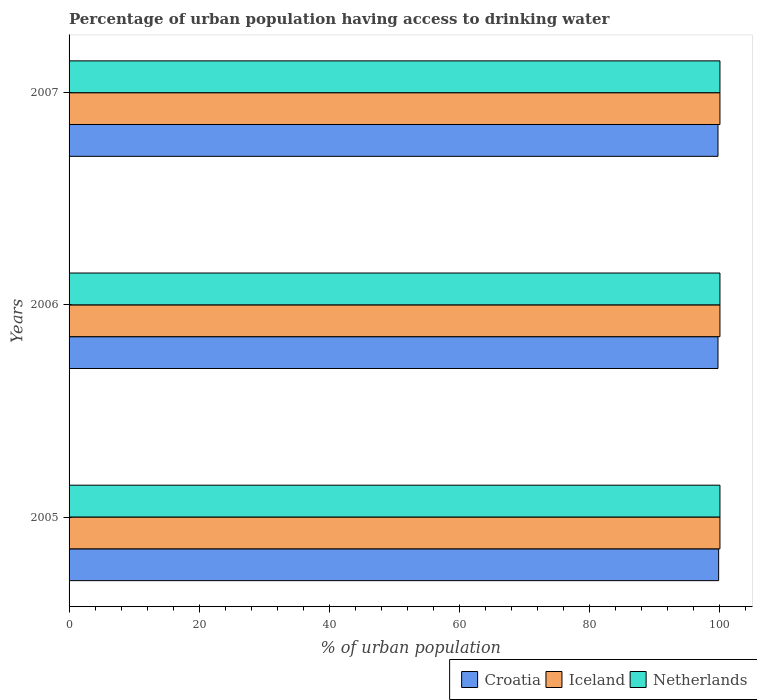How many different coloured bars are there?
Your answer should be compact. 3. How many groups of bars are there?
Keep it short and to the point. 3. Are the number of bars on each tick of the Y-axis equal?
Make the answer very short. Yes. How many bars are there on the 1st tick from the bottom?
Offer a very short reply. 3. What is the percentage of urban population having access to drinking water in Netherlands in 2005?
Your answer should be very brief. 100. Across all years, what is the maximum percentage of urban population having access to drinking water in Croatia?
Give a very brief answer. 99.8. Across all years, what is the minimum percentage of urban population having access to drinking water in Iceland?
Your answer should be very brief. 100. In which year was the percentage of urban population having access to drinking water in Croatia minimum?
Your answer should be very brief. 2006. What is the total percentage of urban population having access to drinking water in Croatia in the graph?
Keep it short and to the point. 299.2. What is the difference between the percentage of urban population having access to drinking water in Netherlands in 2006 and the percentage of urban population having access to drinking water in Croatia in 2005?
Your response must be concise. 0.2. What is the average percentage of urban population having access to drinking water in Iceland per year?
Your answer should be compact. 100. In the year 2006, what is the difference between the percentage of urban population having access to drinking water in Iceland and percentage of urban population having access to drinking water in Croatia?
Make the answer very short. 0.3. In how many years, is the percentage of urban population having access to drinking water in Iceland greater than 48 %?
Make the answer very short. 3. What is the difference between the highest and the lowest percentage of urban population having access to drinking water in Netherlands?
Ensure brevity in your answer.  0. In how many years, is the percentage of urban population having access to drinking water in Croatia greater than the average percentage of urban population having access to drinking water in Croatia taken over all years?
Offer a very short reply. 1. Is the sum of the percentage of urban population having access to drinking water in Iceland in 2006 and 2007 greater than the maximum percentage of urban population having access to drinking water in Croatia across all years?
Provide a succinct answer. Yes. What does the 2nd bar from the bottom in 2007 represents?
Your answer should be very brief. Iceland. Are all the bars in the graph horizontal?
Offer a very short reply. Yes. How many years are there in the graph?
Ensure brevity in your answer.  3. What is the difference between two consecutive major ticks on the X-axis?
Your answer should be very brief. 20. Does the graph contain any zero values?
Your answer should be very brief. No. Does the graph contain grids?
Make the answer very short. No. Where does the legend appear in the graph?
Offer a terse response. Bottom right. What is the title of the graph?
Keep it short and to the point. Percentage of urban population having access to drinking water. What is the label or title of the X-axis?
Your response must be concise. % of urban population. What is the label or title of the Y-axis?
Keep it short and to the point. Years. What is the % of urban population of Croatia in 2005?
Provide a succinct answer. 99.8. What is the % of urban population of Croatia in 2006?
Your answer should be very brief. 99.7. What is the % of urban population in Croatia in 2007?
Offer a terse response. 99.7. What is the % of urban population in Iceland in 2007?
Your response must be concise. 100. Across all years, what is the maximum % of urban population in Croatia?
Your answer should be compact. 99.8. Across all years, what is the maximum % of urban population in Iceland?
Your answer should be very brief. 100. Across all years, what is the maximum % of urban population of Netherlands?
Offer a very short reply. 100. Across all years, what is the minimum % of urban population in Croatia?
Keep it short and to the point. 99.7. Across all years, what is the minimum % of urban population in Iceland?
Keep it short and to the point. 100. What is the total % of urban population of Croatia in the graph?
Give a very brief answer. 299.2. What is the total % of urban population of Iceland in the graph?
Your answer should be compact. 300. What is the total % of urban population in Netherlands in the graph?
Provide a succinct answer. 300. What is the difference between the % of urban population in Iceland in 2005 and that in 2006?
Provide a succinct answer. 0. What is the difference between the % of urban population in Netherlands in 2005 and that in 2006?
Your answer should be compact. 0. What is the difference between the % of urban population of Croatia in 2005 and that in 2007?
Offer a very short reply. 0.1. What is the difference between the % of urban population in Iceland in 2005 and that in 2007?
Provide a short and direct response. 0. What is the difference between the % of urban population in Netherlands in 2005 and that in 2007?
Provide a short and direct response. 0. What is the difference between the % of urban population of Croatia in 2006 and that in 2007?
Your answer should be very brief. 0. What is the difference between the % of urban population of Iceland in 2006 and that in 2007?
Your answer should be compact. 0. What is the difference between the % of urban population in Netherlands in 2006 and that in 2007?
Your response must be concise. 0. What is the difference between the % of urban population of Croatia in 2005 and the % of urban population of Iceland in 2006?
Your answer should be very brief. -0.2. What is the difference between the % of urban population of Croatia in 2005 and the % of urban population of Iceland in 2007?
Offer a very short reply. -0.2. What is the difference between the % of urban population in Croatia in 2005 and the % of urban population in Netherlands in 2007?
Keep it short and to the point. -0.2. What is the difference between the % of urban population in Croatia in 2006 and the % of urban population in Iceland in 2007?
Provide a short and direct response. -0.3. What is the difference between the % of urban population of Iceland in 2006 and the % of urban population of Netherlands in 2007?
Provide a short and direct response. 0. What is the average % of urban population of Croatia per year?
Your response must be concise. 99.73. What is the average % of urban population in Iceland per year?
Provide a succinct answer. 100. What is the average % of urban population in Netherlands per year?
Make the answer very short. 100. In the year 2005, what is the difference between the % of urban population in Croatia and % of urban population in Iceland?
Offer a terse response. -0.2. In the year 2005, what is the difference between the % of urban population of Croatia and % of urban population of Netherlands?
Ensure brevity in your answer.  -0.2. In the year 2006, what is the difference between the % of urban population of Croatia and % of urban population of Iceland?
Your answer should be compact. -0.3. In the year 2006, what is the difference between the % of urban population in Croatia and % of urban population in Netherlands?
Give a very brief answer. -0.3. In the year 2006, what is the difference between the % of urban population in Iceland and % of urban population in Netherlands?
Offer a terse response. 0. In the year 2007, what is the difference between the % of urban population of Croatia and % of urban population of Iceland?
Provide a succinct answer. -0.3. What is the ratio of the % of urban population in Croatia in 2005 to that in 2006?
Your answer should be very brief. 1. What is the ratio of the % of urban population of Iceland in 2005 to that in 2006?
Provide a short and direct response. 1. What is the ratio of the % of urban population of Netherlands in 2005 to that in 2006?
Keep it short and to the point. 1. What is the ratio of the % of urban population in Croatia in 2005 to that in 2007?
Give a very brief answer. 1. What is the ratio of the % of urban population in Iceland in 2005 to that in 2007?
Give a very brief answer. 1. What is the ratio of the % of urban population in Croatia in 2006 to that in 2007?
Keep it short and to the point. 1. What is the ratio of the % of urban population of Netherlands in 2006 to that in 2007?
Offer a terse response. 1. What is the difference between the highest and the second highest % of urban population of Croatia?
Keep it short and to the point. 0.1. What is the difference between the highest and the second highest % of urban population in Iceland?
Make the answer very short. 0. What is the difference between the highest and the second highest % of urban population in Netherlands?
Ensure brevity in your answer.  0. What is the difference between the highest and the lowest % of urban population of Croatia?
Give a very brief answer. 0.1. What is the difference between the highest and the lowest % of urban population in Iceland?
Offer a very short reply. 0. What is the difference between the highest and the lowest % of urban population of Netherlands?
Ensure brevity in your answer.  0. 